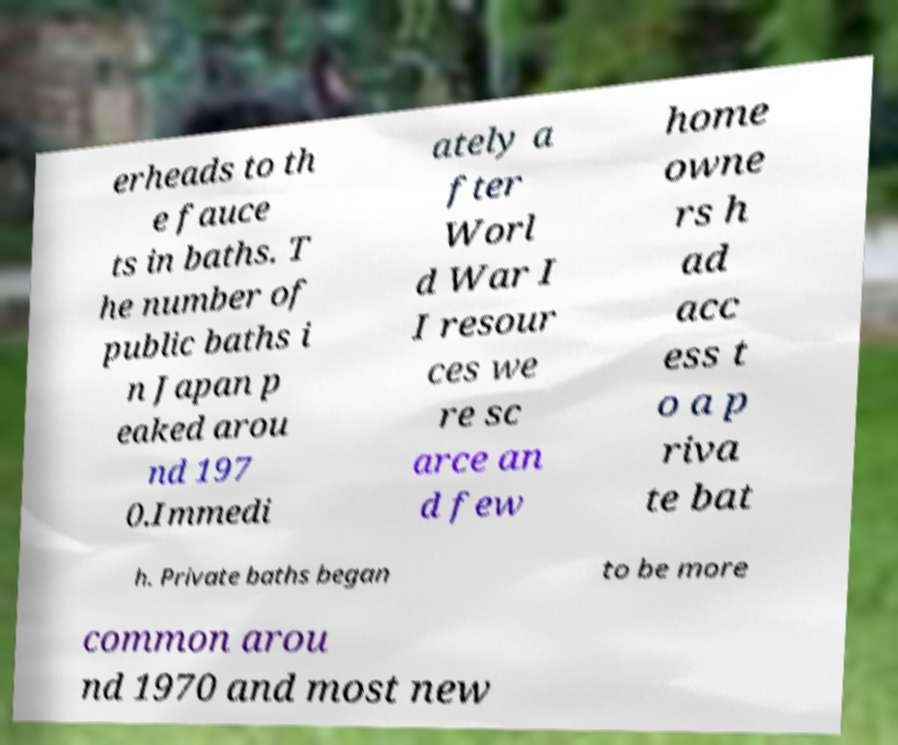Please read and relay the text visible in this image. What does it say? erheads to th e fauce ts in baths. T he number of public baths i n Japan p eaked arou nd 197 0.Immedi ately a fter Worl d War I I resour ces we re sc arce an d few home owne rs h ad acc ess t o a p riva te bat h. Private baths began to be more common arou nd 1970 and most new 